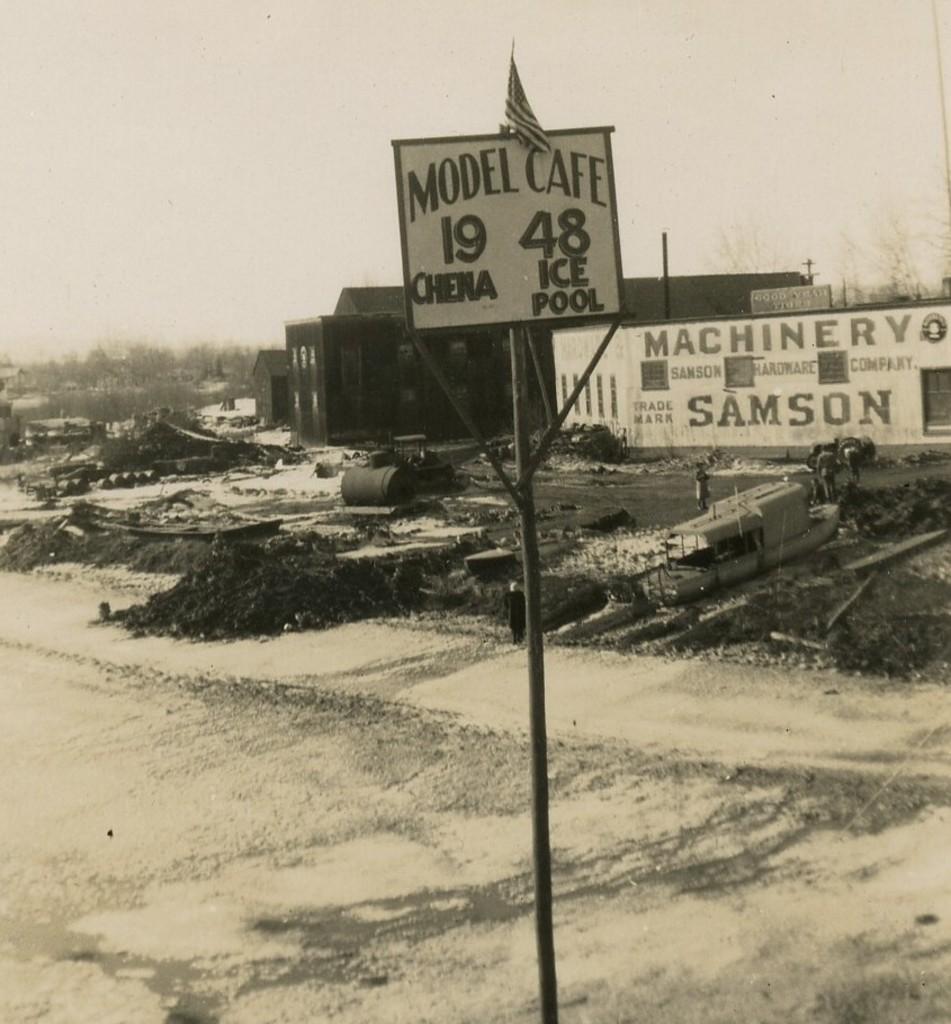Can you describe this image briefly? In this image I can see the board and flag to the pole. In the background I can see the boat, mud, some objects and few people standing. I can also see the buildings and something is written on the wall of the building, trees and the sky. 